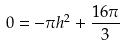<formula> <loc_0><loc_0><loc_500><loc_500>0 = - \pi h ^ { 2 } + \frac { 1 6 \pi } { 3 }</formula> 